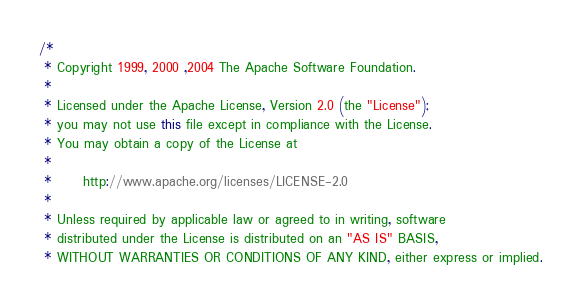<code> <loc_0><loc_0><loc_500><loc_500><_Java_>/*
 * Copyright 1999, 2000 ,2004 The Apache Software Foundation.
 * 
 * Licensed under the Apache License, Version 2.0 (the "License");
 * you may not use this file except in compliance with the License.
 * You may obtain a copy of the License at
 * 
 *      http://www.apache.org/licenses/LICENSE-2.0
 * 
 * Unless required by applicable law or agreed to in writing, software
 * distributed under the License is distributed on an "AS IS" BASIS,
 * WITHOUT WARRANTIES OR CONDITIONS OF ANY KIND, either express or implied.</code> 